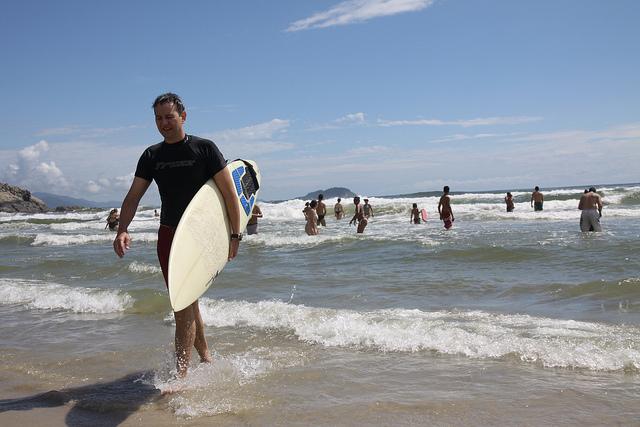Are they at the beach?
Quick response, please. Yes. Does it look as if it might be early in the year for suntans yet?
Write a very short answer. Yes. What is the man carrying?
Write a very short answer. Surfboard. 